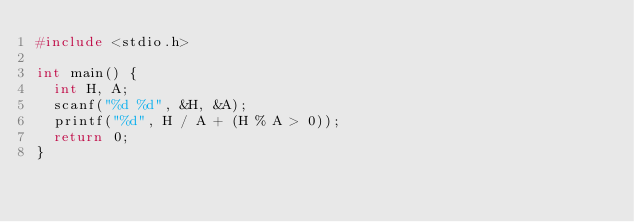<code> <loc_0><loc_0><loc_500><loc_500><_C++_>#include <stdio.h>

int main() {
  int H, A;
  scanf("%d %d", &H, &A);
  printf("%d", H / A + (H % A > 0));
  return 0;
}</code> 